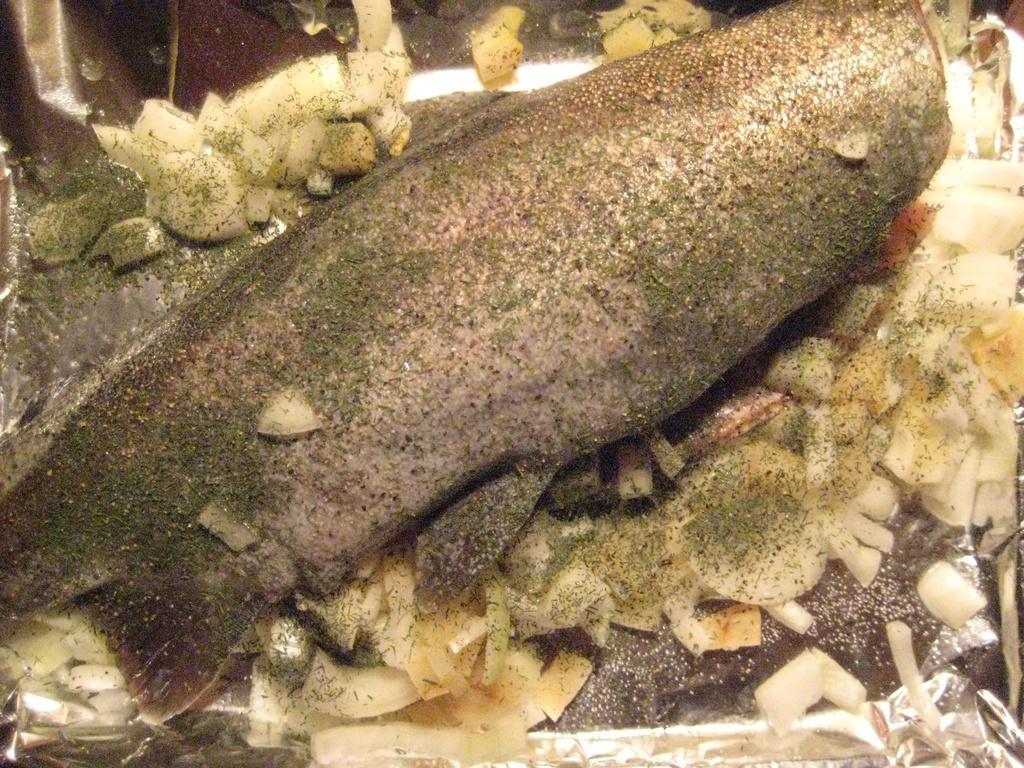Could you give a brief overview of what you see in this image? In this image there is a fish which looks like a food. 